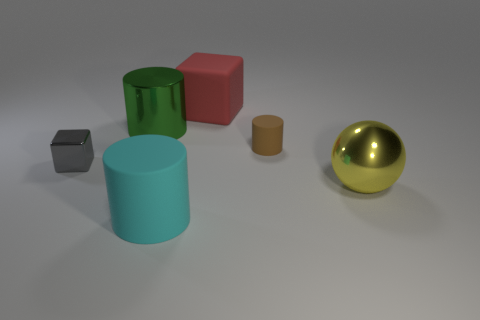Add 1 small red rubber blocks. How many objects exist? 7 Subtract all balls. How many objects are left? 5 Subtract 1 cyan cylinders. How many objects are left? 5 Subtract all large red cylinders. Subtract all red matte things. How many objects are left? 5 Add 1 big yellow objects. How many big yellow objects are left? 2 Add 2 large cyan metal objects. How many large cyan metal objects exist? 2 